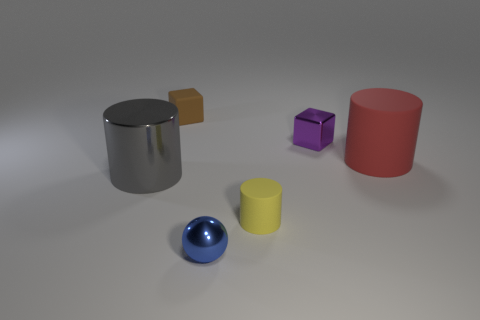Add 3 purple metallic cubes. How many objects exist? 9 Subtract all balls. How many objects are left? 5 Subtract all small blue metallic things. Subtract all tiny objects. How many objects are left? 1 Add 6 small blue metal balls. How many small blue metal balls are left? 7 Add 5 tiny blue metal spheres. How many tiny blue metal spheres exist? 6 Subtract 0 cyan blocks. How many objects are left? 6 